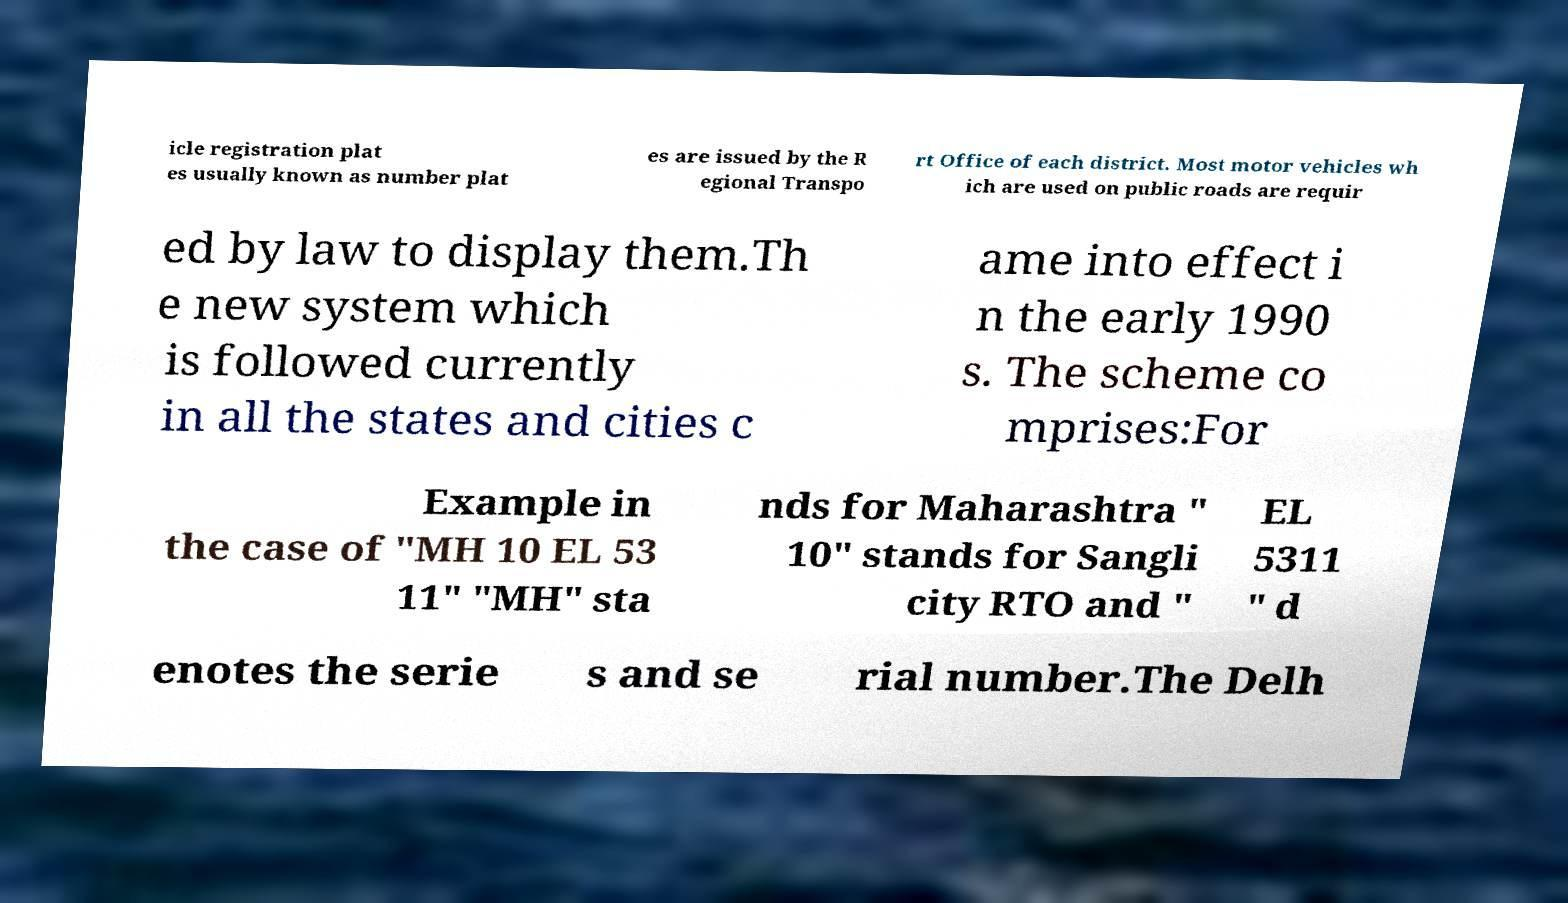Can you read and provide the text displayed in the image?This photo seems to have some interesting text. Can you extract and type it out for me? icle registration plat es usually known as number plat es are issued by the R egional Transpo rt Office of each district. Most motor vehicles wh ich are used on public roads are requir ed by law to display them.Th e new system which is followed currently in all the states and cities c ame into effect i n the early 1990 s. The scheme co mprises:For Example in the case of "MH 10 EL 53 11" "MH" sta nds for Maharashtra " 10" stands for Sangli city RTO and " EL 5311 " d enotes the serie s and se rial number.The Delh 